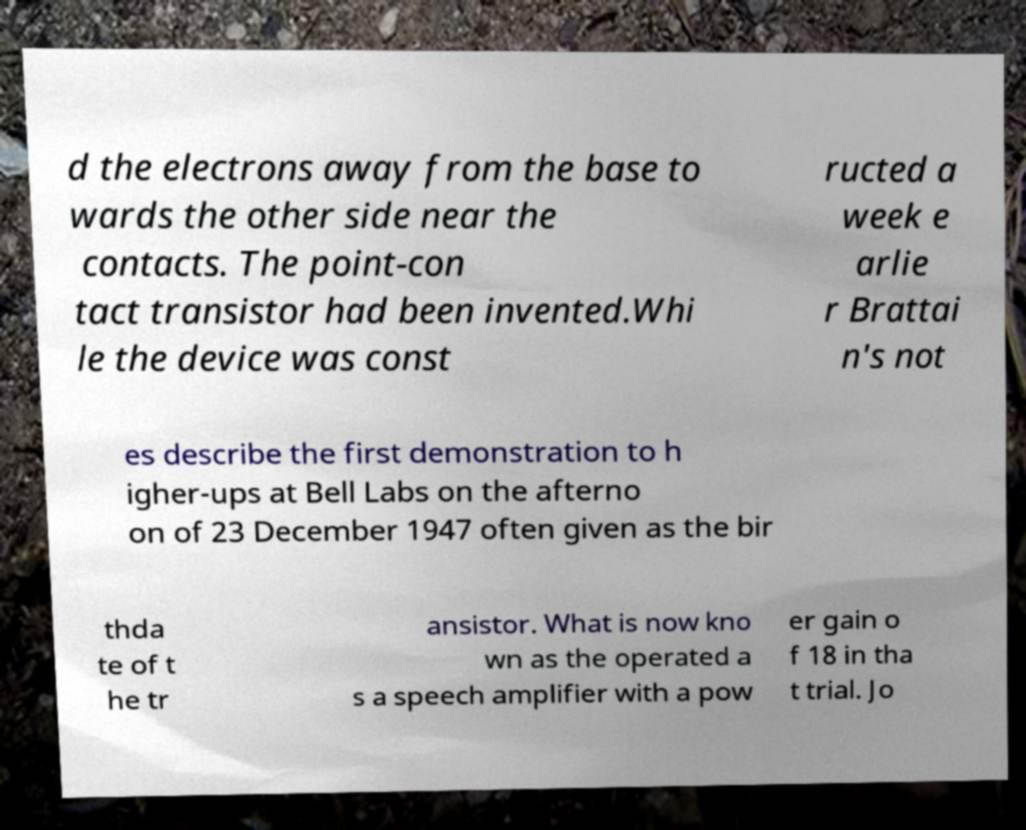Can you read and provide the text displayed in the image?This photo seems to have some interesting text. Can you extract and type it out for me? d the electrons away from the base to wards the other side near the contacts. The point-con tact transistor had been invented.Whi le the device was const ructed a week e arlie r Brattai n's not es describe the first demonstration to h igher-ups at Bell Labs on the afterno on of 23 December 1947 often given as the bir thda te of t he tr ansistor. What is now kno wn as the operated a s a speech amplifier with a pow er gain o f 18 in tha t trial. Jo 